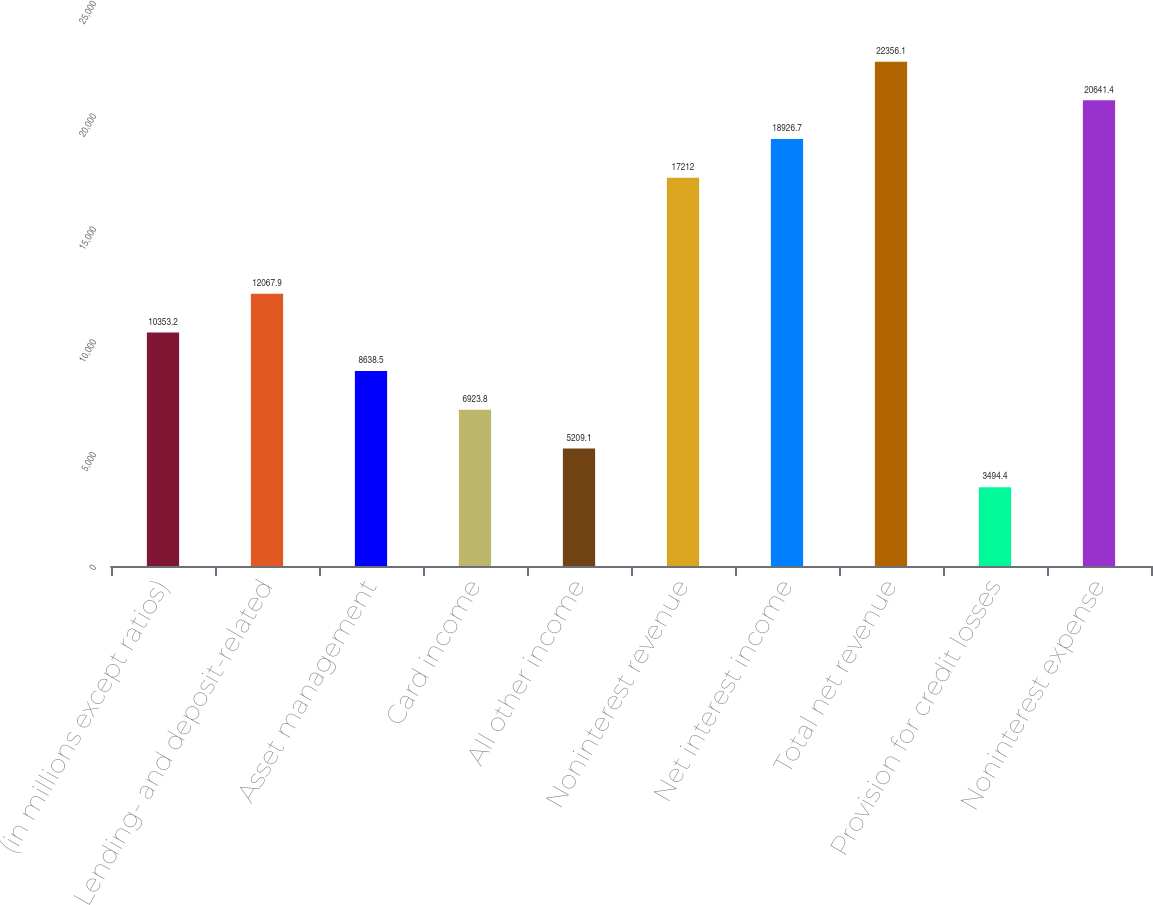<chart> <loc_0><loc_0><loc_500><loc_500><bar_chart><fcel>(in millions except ratios)<fcel>Lending- and deposit-related<fcel>Asset management<fcel>Card income<fcel>All other income<fcel>Noninterest revenue<fcel>Net interest income<fcel>Total net revenue<fcel>Provision for credit losses<fcel>Noninterest expense<nl><fcel>10353.2<fcel>12067.9<fcel>8638.5<fcel>6923.8<fcel>5209.1<fcel>17212<fcel>18926.7<fcel>22356.1<fcel>3494.4<fcel>20641.4<nl></chart> 